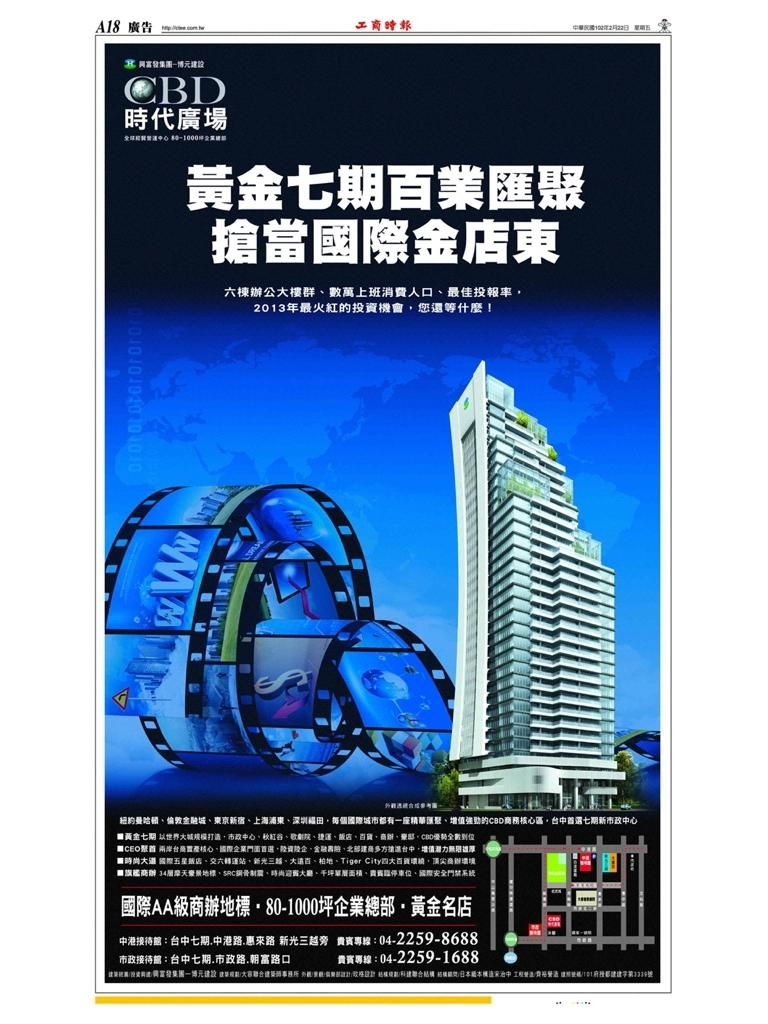<image>
Create a compact narrative representing the image presented. a tall building on a news ad with CBD at the top and Japanese writing 